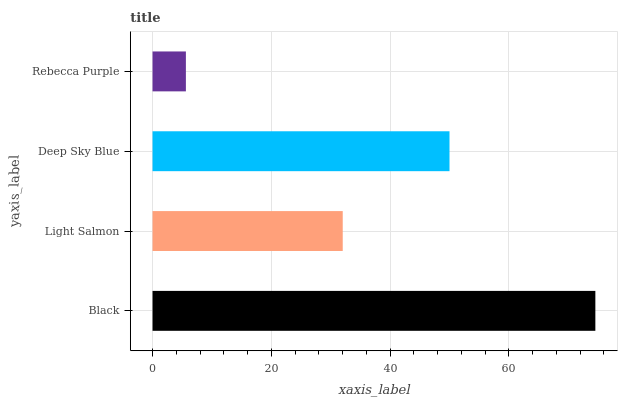Is Rebecca Purple the minimum?
Answer yes or no. Yes. Is Black the maximum?
Answer yes or no. Yes. Is Light Salmon the minimum?
Answer yes or no. No. Is Light Salmon the maximum?
Answer yes or no. No. Is Black greater than Light Salmon?
Answer yes or no. Yes. Is Light Salmon less than Black?
Answer yes or no. Yes. Is Light Salmon greater than Black?
Answer yes or no. No. Is Black less than Light Salmon?
Answer yes or no. No. Is Deep Sky Blue the high median?
Answer yes or no. Yes. Is Light Salmon the low median?
Answer yes or no. Yes. Is Black the high median?
Answer yes or no. No. Is Black the low median?
Answer yes or no. No. 